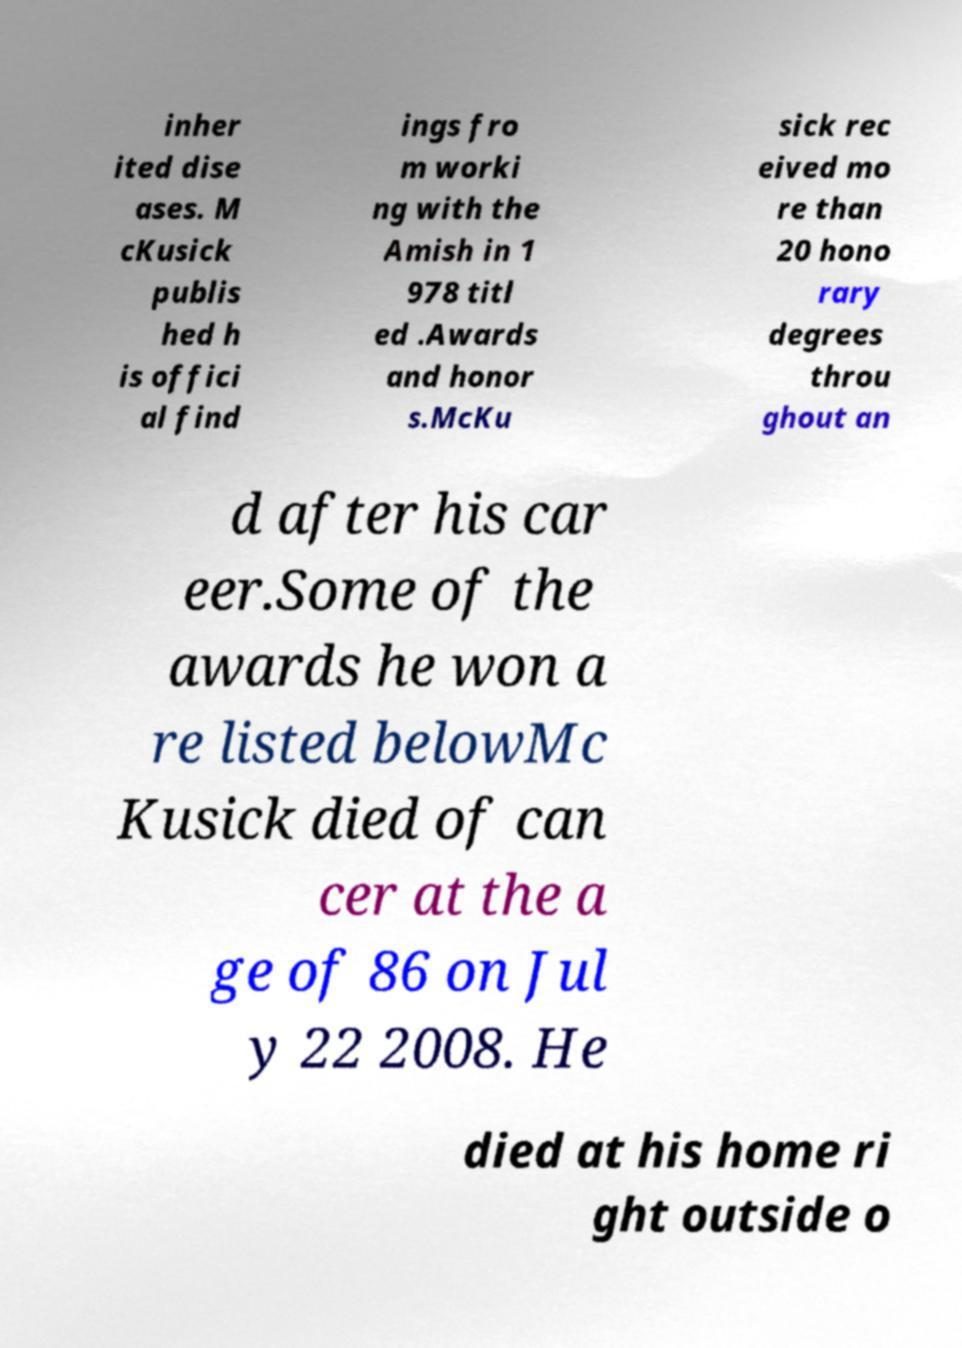Can you read and provide the text displayed in the image?This photo seems to have some interesting text. Can you extract and type it out for me? inher ited dise ases. M cKusick publis hed h is offici al find ings fro m worki ng with the Amish in 1 978 titl ed .Awards and honor s.McKu sick rec eived mo re than 20 hono rary degrees throu ghout an d after his car eer.Some of the awards he won a re listed belowMc Kusick died of can cer at the a ge of 86 on Jul y 22 2008. He died at his home ri ght outside o 